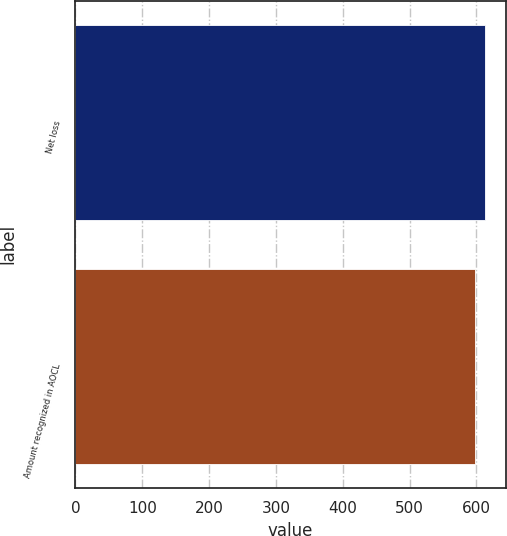<chart> <loc_0><loc_0><loc_500><loc_500><bar_chart><fcel>Net loss<fcel>Amount recognized in AOCL<nl><fcel>613.2<fcel>597.5<nl></chart> 